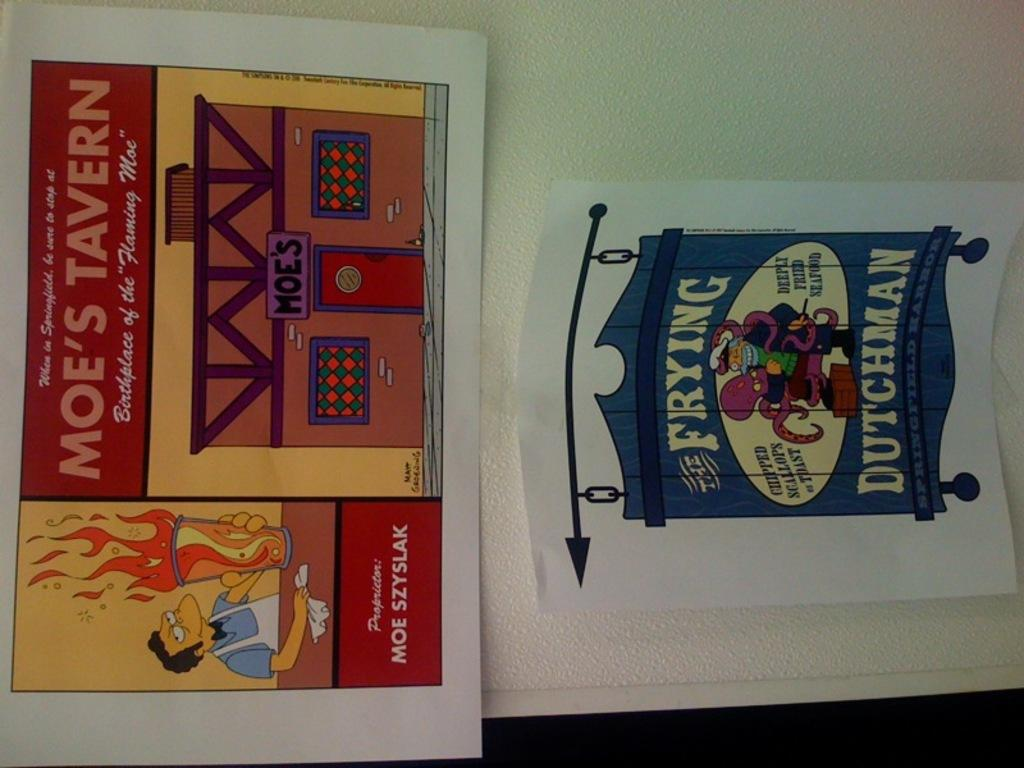<image>
Relay a brief, clear account of the picture shown. the word frying is on an ad with a Simpsons character 